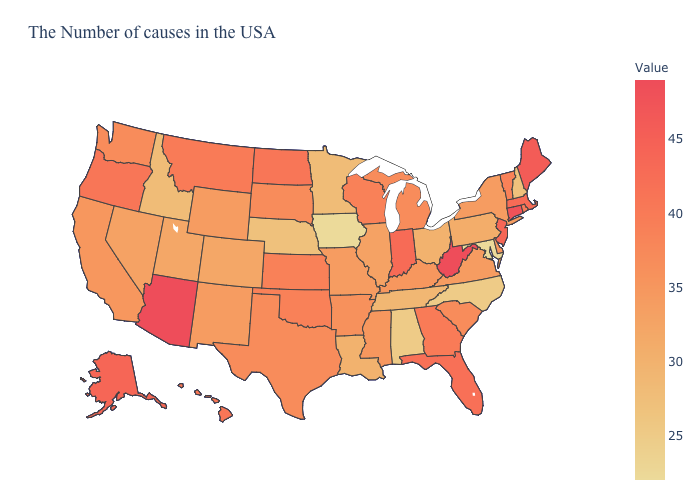Does Hawaii have the highest value in the USA?
Answer briefly. No. Is the legend a continuous bar?
Concise answer only. Yes. Which states have the lowest value in the USA?
Answer briefly. Maryland, Iowa. Among the states that border Utah , does Colorado have the lowest value?
Quick response, please. No. Does Massachusetts have a lower value than West Virginia?
Keep it brief. Yes. Among the states that border Maryland , does Virginia have the highest value?
Write a very short answer. No. Does Delaware have the lowest value in the USA?
Concise answer only. No. Does North Dakota have the highest value in the USA?
Concise answer only. No. 